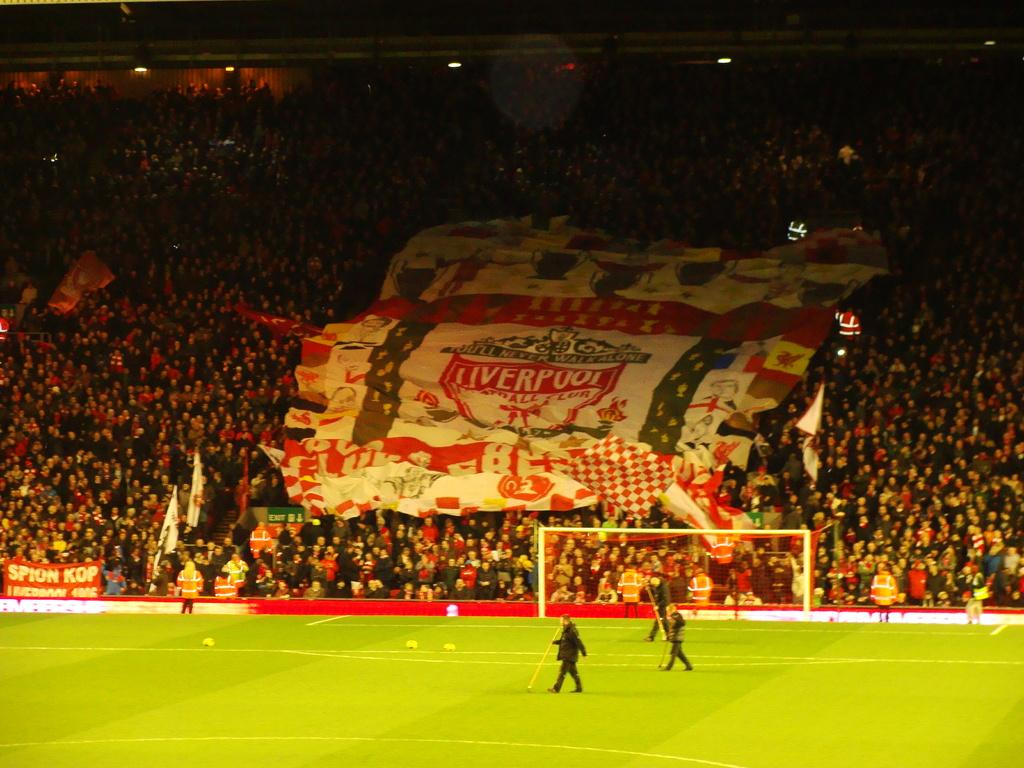<image>
Present a compact description of the photo's key features. The massive sign in the stand with the supporters is for liverpool. 